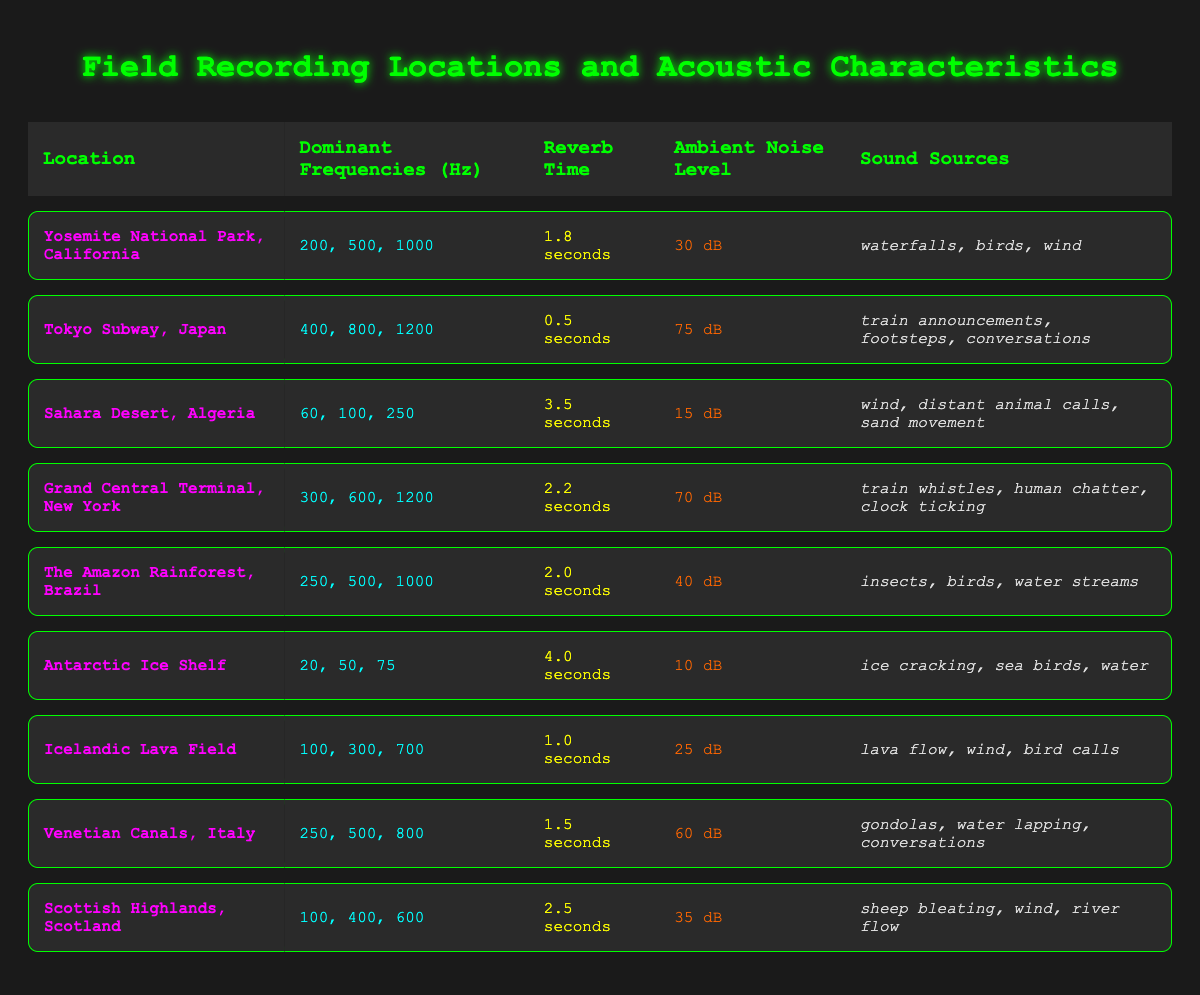What is the reverb time for the Sahara Desert? From the table, locate the Sahara Desert row and find the "Reverb Time" column. It shows "3.5 seconds" as the value.
Answer: 3.5 seconds Which location has the highest ambient noise level? By comparing the "Ambient Noise Level" values from all locations in the table, the Tokyo Subway at "75 dB" is the highest.
Answer: Tokyo Subway What sound sources can be found in the Amazon Rainforest? Look at the row for "The Amazon Rainforest" and check the "Sound Sources" column, which lists "insects, birds, water streams".
Answer: insects, birds, water streams What are the dominant frequencies for the Antarctic Ice Shelf? Find the row for the Antarctic Ice Shelf and refer to the "Dominant Frequencies" column, which lists "20, 50, 75".
Answer: 20, 50, 75 Is the average ambient noise level greater than 40 dB? To find the average ambient noise level, sum all ambient noise levels: (30 + 75 + 15 + 70 + 40 + 10 + 25 + 60 + 35) = 320 dB. There are 9 locations, so the average is 320/9 = 35.56 dB, which is less than 40 dB.
Answer: No Which location has the longest reverb time and what is it? Check all the “Reverb Time” values in the table. The Antarctic Ice Shelf has "4.0 seconds", which is the longest.
Answer: Antarctic Ice Shelf, 4.0 seconds Count the total number of unique sound sources found in the Venetian Canals. Refer to the "Sound Sources" column for the Venetian Canals, which lists "gondolas, water lapping, conversations". There are 3 unique sources.
Answer: 3 What is the difference in reverb time between the Tokyo Subway and the Yosemite National Park? The reverb time for Tokyo Subway is "0.5 seconds" and for Yosemite is "1.8 seconds". Thus, the difference is 1.8 - 0.5 = 1.3 seconds.
Answer: 1.3 seconds Are there more locations with an ambient noise level below 30 dB than above? Check the ambient noise levels: Only the Arctic Ice Shelf (10 dB), Sahara Desert (15 dB), and Yosemite Park (30 dB) are below or equal to 30 dB (3 locations), while Tokyo Subway (75 dB), Grand Central (70 dB), Amazon Rainforest (40 dB), Icelandic Lava Field (25 dB), Venetian Canals (60 dB), and Scottish Highlands (35 dB) are above (6 locations). So there are more locations above.
Answer: No What is the average dominant frequency of the Grand Central Terminal? For Grand Central Terminal, the dominant frequencies are 300, 600, 1200. The average is (300 + 600 + 1200)/3 = 700 Hz.
Answer: 700 Hz 